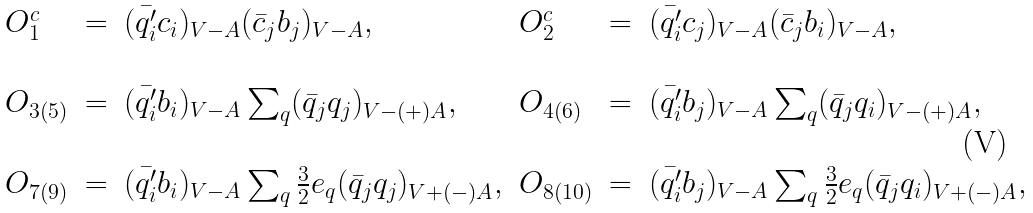<formula> <loc_0><loc_0><loc_500><loc_500>\begin{array} { l l l l l l } O _ { 1 } ^ { c } & = & ( \bar { q _ { i } ^ { \prime } } c _ { i } ) _ { V - A } ( \bar { c } _ { j } b _ { j } ) _ { V - A } , & O _ { 2 } ^ { c } & = & ( \bar { q _ { i } ^ { \prime } } c _ { j } ) _ { V - A } ( \bar { c } _ { j } b _ { i } ) _ { V - A } , \\ \\ O _ { 3 ( 5 ) } & = & ( \bar { q _ { i } ^ { \prime } } b _ { i } ) _ { V - A } \sum _ { q } ( \bar { q } _ { j } q _ { j } ) _ { V - ( + ) A } , & O _ { 4 ( 6 ) } & = & ( \bar { q _ { i } ^ { \prime } } b _ { j } ) _ { V - A } \sum _ { q } ( \bar { q } _ { j } q _ { i } ) _ { V - ( + ) A } , \\ \\ O _ { 7 ( 9 ) } & = & ( \bar { q _ { i } ^ { \prime } } b _ { i } ) _ { V - A } \sum _ { q } { \frac { 3 } { 2 } } e _ { q } ( \bar { q } _ { j } q _ { j } ) _ { V + ( - ) A } , & O _ { 8 ( 1 0 ) } & = & ( \bar { q _ { i } ^ { \prime } } b _ { j } ) _ { V - A } \sum _ { q } { \frac { 3 } { 2 } } e _ { q } ( \bar { q } _ { j } q _ { i } ) _ { V + ( - ) A } , \end{array}</formula> 